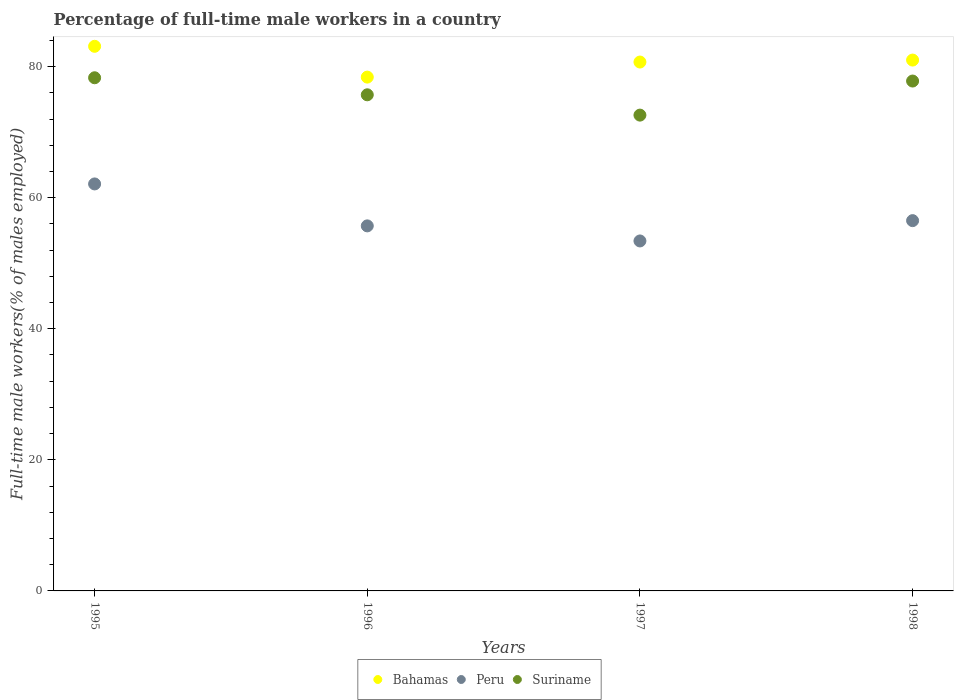Is the number of dotlines equal to the number of legend labels?
Provide a short and direct response. Yes. What is the percentage of full-time male workers in Suriname in 1996?
Provide a succinct answer. 75.7. Across all years, what is the maximum percentage of full-time male workers in Peru?
Ensure brevity in your answer.  62.1. Across all years, what is the minimum percentage of full-time male workers in Peru?
Your answer should be compact. 53.4. What is the total percentage of full-time male workers in Bahamas in the graph?
Your answer should be very brief. 323.2. What is the difference between the percentage of full-time male workers in Suriname in 1996 and that in 1998?
Provide a succinct answer. -2.1. What is the difference between the percentage of full-time male workers in Peru in 1998 and the percentage of full-time male workers in Bahamas in 1997?
Offer a very short reply. -24.2. What is the average percentage of full-time male workers in Bahamas per year?
Offer a terse response. 80.8. In the year 1997, what is the difference between the percentage of full-time male workers in Suriname and percentage of full-time male workers in Bahamas?
Ensure brevity in your answer.  -8.1. What is the ratio of the percentage of full-time male workers in Suriname in 1996 to that in 1997?
Your answer should be compact. 1.04. Is the percentage of full-time male workers in Bahamas in 1995 less than that in 1997?
Keep it short and to the point. No. Is the difference between the percentage of full-time male workers in Suriname in 1997 and 1998 greater than the difference between the percentage of full-time male workers in Bahamas in 1997 and 1998?
Make the answer very short. No. What is the difference between the highest and the lowest percentage of full-time male workers in Bahamas?
Your answer should be very brief. 4.7. Is the sum of the percentage of full-time male workers in Bahamas in 1995 and 1996 greater than the maximum percentage of full-time male workers in Suriname across all years?
Give a very brief answer. Yes. Is it the case that in every year, the sum of the percentage of full-time male workers in Suriname and percentage of full-time male workers in Peru  is greater than the percentage of full-time male workers in Bahamas?
Ensure brevity in your answer.  Yes. Is the percentage of full-time male workers in Peru strictly less than the percentage of full-time male workers in Bahamas over the years?
Offer a terse response. Yes. How many dotlines are there?
Your answer should be compact. 3. Are the values on the major ticks of Y-axis written in scientific E-notation?
Give a very brief answer. No. Where does the legend appear in the graph?
Offer a very short reply. Bottom center. How many legend labels are there?
Provide a succinct answer. 3. How are the legend labels stacked?
Your answer should be very brief. Horizontal. What is the title of the graph?
Your answer should be compact. Percentage of full-time male workers in a country. Does "Guinea-Bissau" appear as one of the legend labels in the graph?
Your answer should be compact. No. What is the label or title of the X-axis?
Keep it short and to the point. Years. What is the label or title of the Y-axis?
Make the answer very short. Full-time male workers(% of males employed). What is the Full-time male workers(% of males employed) of Bahamas in 1995?
Provide a succinct answer. 83.1. What is the Full-time male workers(% of males employed) in Peru in 1995?
Provide a succinct answer. 62.1. What is the Full-time male workers(% of males employed) of Suriname in 1995?
Your answer should be very brief. 78.3. What is the Full-time male workers(% of males employed) in Bahamas in 1996?
Give a very brief answer. 78.4. What is the Full-time male workers(% of males employed) of Peru in 1996?
Ensure brevity in your answer.  55.7. What is the Full-time male workers(% of males employed) of Suriname in 1996?
Give a very brief answer. 75.7. What is the Full-time male workers(% of males employed) in Bahamas in 1997?
Provide a succinct answer. 80.7. What is the Full-time male workers(% of males employed) in Peru in 1997?
Your response must be concise. 53.4. What is the Full-time male workers(% of males employed) in Suriname in 1997?
Ensure brevity in your answer.  72.6. What is the Full-time male workers(% of males employed) in Peru in 1998?
Provide a short and direct response. 56.5. What is the Full-time male workers(% of males employed) of Suriname in 1998?
Provide a succinct answer. 77.8. Across all years, what is the maximum Full-time male workers(% of males employed) in Bahamas?
Your answer should be very brief. 83.1. Across all years, what is the maximum Full-time male workers(% of males employed) in Peru?
Offer a terse response. 62.1. Across all years, what is the maximum Full-time male workers(% of males employed) in Suriname?
Your answer should be compact. 78.3. Across all years, what is the minimum Full-time male workers(% of males employed) of Bahamas?
Your answer should be compact. 78.4. Across all years, what is the minimum Full-time male workers(% of males employed) in Peru?
Keep it short and to the point. 53.4. Across all years, what is the minimum Full-time male workers(% of males employed) of Suriname?
Offer a very short reply. 72.6. What is the total Full-time male workers(% of males employed) in Bahamas in the graph?
Your answer should be compact. 323.2. What is the total Full-time male workers(% of males employed) of Peru in the graph?
Offer a terse response. 227.7. What is the total Full-time male workers(% of males employed) in Suriname in the graph?
Keep it short and to the point. 304.4. What is the difference between the Full-time male workers(% of males employed) of Peru in 1995 and that in 1996?
Your response must be concise. 6.4. What is the difference between the Full-time male workers(% of males employed) in Suriname in 1995 and that in 1996?
Provide a succinct answer. 2.6. What is the difference between the Full-time male workers(% of males employed) of Peru in 1995 and that in 1997?
Give a very brief answer. 8.7. What is the difference between the Full-time male workers(% of males employed) of Suriname in 1995 and that in 1997?
Make the answer very short. 5.7. What is the difference between the Full-time male workers(% of males employed) in Bahamas in 1995 and that in 1998?
Offer a terse response. 2.1. What is the difference between the Full-time male workers(% of males employed) in Peru in 1995 and that in 1998?
Offer a very short reply. 5.6. What is the difference between the Full-time male workers(% of males employed) in Suriname in 1995 and that in 1998?
Your answer should be compact. 0.5. What is the difference between the Full-time male workers(% of males employed) of Bahamas in 1996 and that in 1997?
Give a very brief answer. -2.3. What is the difference between the Full-time male workers(% of males employed) of Bahamas in 1997 and that in 1998?
Offer a very short reply. -0.3. What is the difference between the Full-time male workers(% of males employed) in Suriname in 1997 and that in 1998?
Offer a terse response. -5.2. What is the difference between the Full-time male workers(% of males employed) in Bahamas in 1995 and the Full-time male workers(% of males employed) in Peru in 1996?
Keep it short and to the point. 27.4. What is the difference between the Full-time male workers(% of males employed) in Peru in 1995 and the Full-time male workers(% of males employed) in Suriname in 1996?
Provide a succinct answer. -13.6. What is the difference between the Full-time male workers(% of males employed) in Bahamas in 1995 and the Full-time male workers(% of males employed) in Peru in 1997?
Ensure brevity in your answer.  29.7. What is the difference between the Full-time male workers(% of males employed) of Bahamas in 1995 and the Full-time male workers(% of males employed) of Suriname in 1997?
Offer a very short reply. 10.5. What is the difference between the Full-time male workers(% of males employed) of Peru in 1995 and the Full-time male workers(% of males employed) of Suriname in 1997?
Keep it short and to the point. -10.5. What is the difference between the Full-time male workers(% of males employed) in Bahamas in 1995 and the Full-time male workers(% of males employed) in Peru in 1998?
Offer a very short reply. 26.6. What is the difference between the Full-time male workers(% of males employed) of Bahamas in 1995 and the Full-time male workers(% of males employed) of Suriname in 1998?
Keep it short and to the point. 5.3. What is the difference between the Full-time male workers(% of males employed) of Peru in 1995 and the Full-time male workers(% of males employed) of Suriname in 1998?
Ensure brevity in your answer.  -15.7. What is the difference between the Full-time male workers(% of males employed) in Bahamas in 1996 and the Full-time male workers(% of males employed) in Peru in 1997?
Offer a terse response. 25. What is the difference between the Full-time male workers(% of males employed) of Bahamas in 1996 and the Full-time male workers(% of males employed) of Suriname in 1997?
Keep it short and to the point. 5.8. What is the difference between the Full-time male workers(% of males employed) in Peru in 1996 and the Full-time male workers(% of males employed) in Suriname in 1997?
Ensure brevity in your answer.  -16.9. What is the difference between the Full-time male workers(% of males employed) of Bahamas in 1996 and the Full-time male workers(% of males employed) of Peru in 1998?
Offer a terse response. 21.9. What is the difference between the Full-time male workers(% of males employed) in Bahamas in 1996 and the Full-time male workers(% of males employed) in Suriname in 1998?
Offer a very short reply. 0.6. What is the difference between the Full-time male workers(% of males employed) of Peru in 1996 and the Full-time male workers(% of males employed) of Suriname in 1998?
Your answer should be very brief. -22.1. What is the difference between the Full-time male workers(% of males employed) in Bahamas in 1997 and the Full-time male workers(% of males employed) in Peru in 1998?
Offer a very short reply. 24.2. What is the difference between the Full-time male workers(% of males employed) in Peru in 1997 and the Full-time male workers(% of males employed) in Suriname in 1998?
Ensure brevity in your answer.  -24.4. What is the average Full-time male workers(% of males employed) of Bahamas per year?
Your response must be concise. 80.8. What is the average Full-time male workers(% of males employed) in Peru per year?
Your answer should be compact. 56.92. What is the average Full-time male workers(% of males employed) of Suriname per year?
Keep it short and to the point. 76.1. In the year 1995, what is the difference between the Full-time male workers(% of males employed) of Peru and Full-time male workers(% of males employed) of Suriname?
Give a very brief answer. -16.2. In the year 1996, what is the difference between the Full-time male workers(% of males employed) of Bahamas and Full-time male workers(% of males employed) of Peru?
Keep it short and to the point. 22.7. In the year 1997, what is the difference between the Full-time male workers(% of males employed) of Bahamas and Full-time male workers(% of males employed) of Peru?
Give a very brief answer. 27.3. In the year 1997, what is the difference between the Full-time male workers(% of males employed) in Peru and Full-time male workers(% of males employed) in Suriname?
Ensure brevity in your answer.  -19.2. In the year 1998, what is the difference between the Full-time male workers(% of males employed) in Bahamas and Full-time male workers(% of males employed) in Peru?
Your answer should be very brief. 24.5. In the year 1998, what is the difference between the Full-time male workers(% of males employed) of Bahamas and Full-time male workers(% of males employed) of Suriname?
Provide a short and direct response. 3.2. In the year 1998, what is the difference between the Full-time male workers(% of males employed) of Peru and Full-time male workers(% of males employed) of Suriname?
Offer a very short reply. -21.3. What is the ratio of the Full-time male workers(% of males employed) of Bahamas in 1995 to that in 1996?
Your response must be concise. 1.06. What is the ratio of the Full-time male workers(% of males employed) in Peru in 1995 to that in 1996?
Keep it short and to the point. 1.11. What is the ratio of the Full-time male workers(% of males employed) in Suriname in 1995 to that in 1996?
Your response must be concise. 1.03. What is the ratio of the Full-time male workers(% of males employed) of Bahamas in 1995 to that in 1997?
Give a very brief answer. 1.03. What is the ratio of the Full-time male workers(% of males employed) of Peru in 1995 to that in 1997?
Your answer should be compact. 1.16. What is the ratio of the Full-time male workers(% of males employed) in Suriname in 1995 to that in 1997?
Your response must be concise. 1.08. What is the ratio of the Full-time male workers(% of males employed) in Bahamas in 1995 to that in 1998?
Provide a succinct answer. 1.03. What is the ratio of the Full-time male workers(% of males employed) of Peru in 1995 to that in 1998?
Ensure brevity in your answer.  1.1. What is the ratio of the Full-time male workers(% of males employed) in Suriname in 1995 to that in 1998?
Keep it short and to the point. 1.01. What is the ratio of the Full-time male workers(% of males employed) of Bahamas in 1996 to that in 1997?
Give a very brief answer. 0.97. What is the ratio of the Full-time male workers(% of males employed) in Peru in 1996 to that in 1997?
Your response must be concise. 1.04. What is the ratio of the Full-time male workers(% of males employed) of Suriname in 1996 to that in 1997?
Offer a terse response. 1.04. What is the ratio of the Full-time male workers(% of males employed) in Bahamas in 1996 to that in 1998?
Provide a succinct answer. 0.97. What is the ratio of the Full-time male workers(% of males employed) of Peru in 1996 to that in 1998?
Offer a very short reply. 0.99. What is the ratio of the Full-time male workers(% of males employed) of Peru in 1997 to that in 1998?
Offer a terse response. 0.95. What is the ratio of the Full-time male workers(% of males employed) of Suriname in 1997 to that in 1998?
Keep it short and to the point. 0.93. What is the difference between the highest and the second highest Full-time male workers(% of males employed) in Suriname?
Your answer should be very brief. 0.5. What is the difference between the highest and the lowest Full-time male workers(% of males employed) of Bahamas?
Your response must be concise. 4.7. What is the difference between the highest and the lowest Full-time male workers(% of males employed) of Peru?
Keep it short and to the point. 8.7. What is the difference between the highest and the lowest Full-time male workers(% of males employed) in Suriname?
Keep it short and to the point. 5.7. 